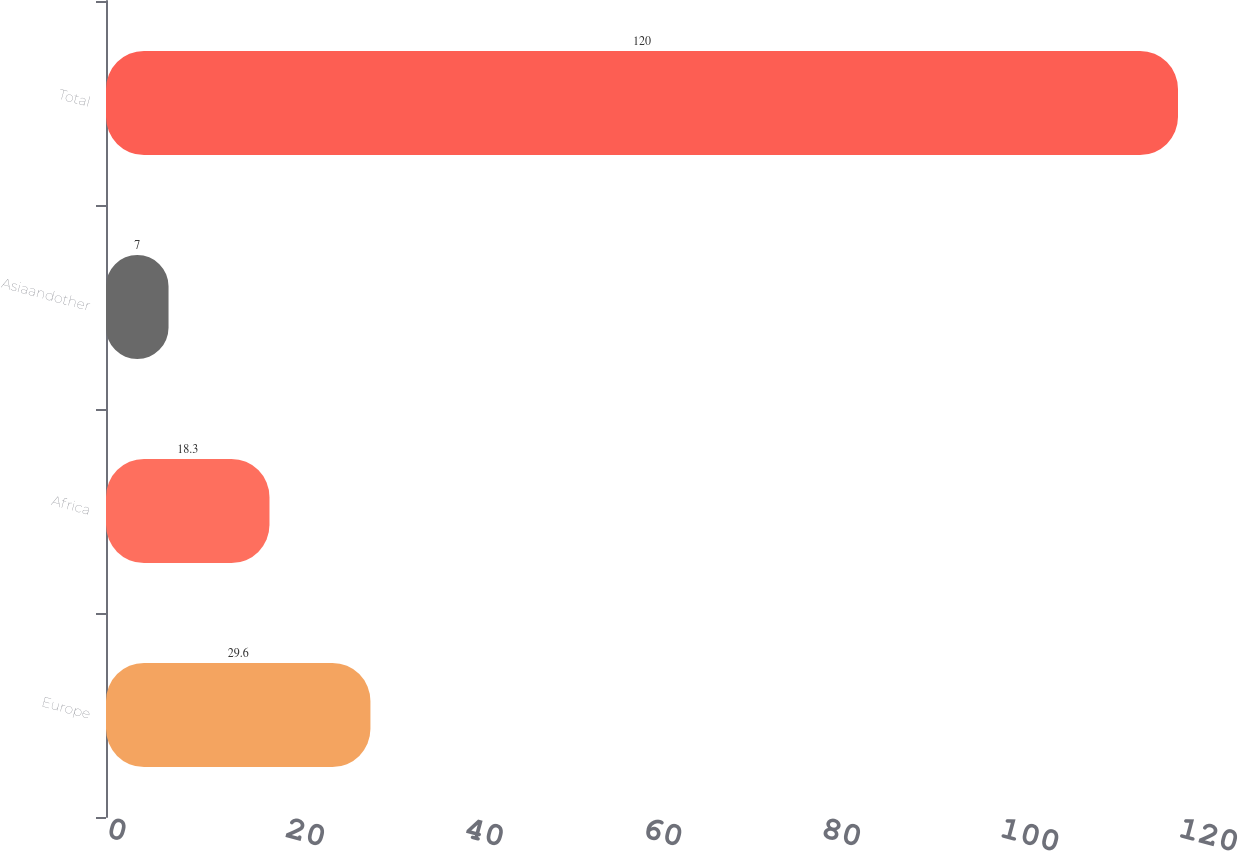<chart> <loc_0><loc_0><loc_500><loc_500><bar_chart><fcel>Europe<fcel>Africa<fcel>Asiaandother<fcel>Total<nl><fcel>29.6<fcel>18.3<fcel>7<fcel>120<nl></chart> 